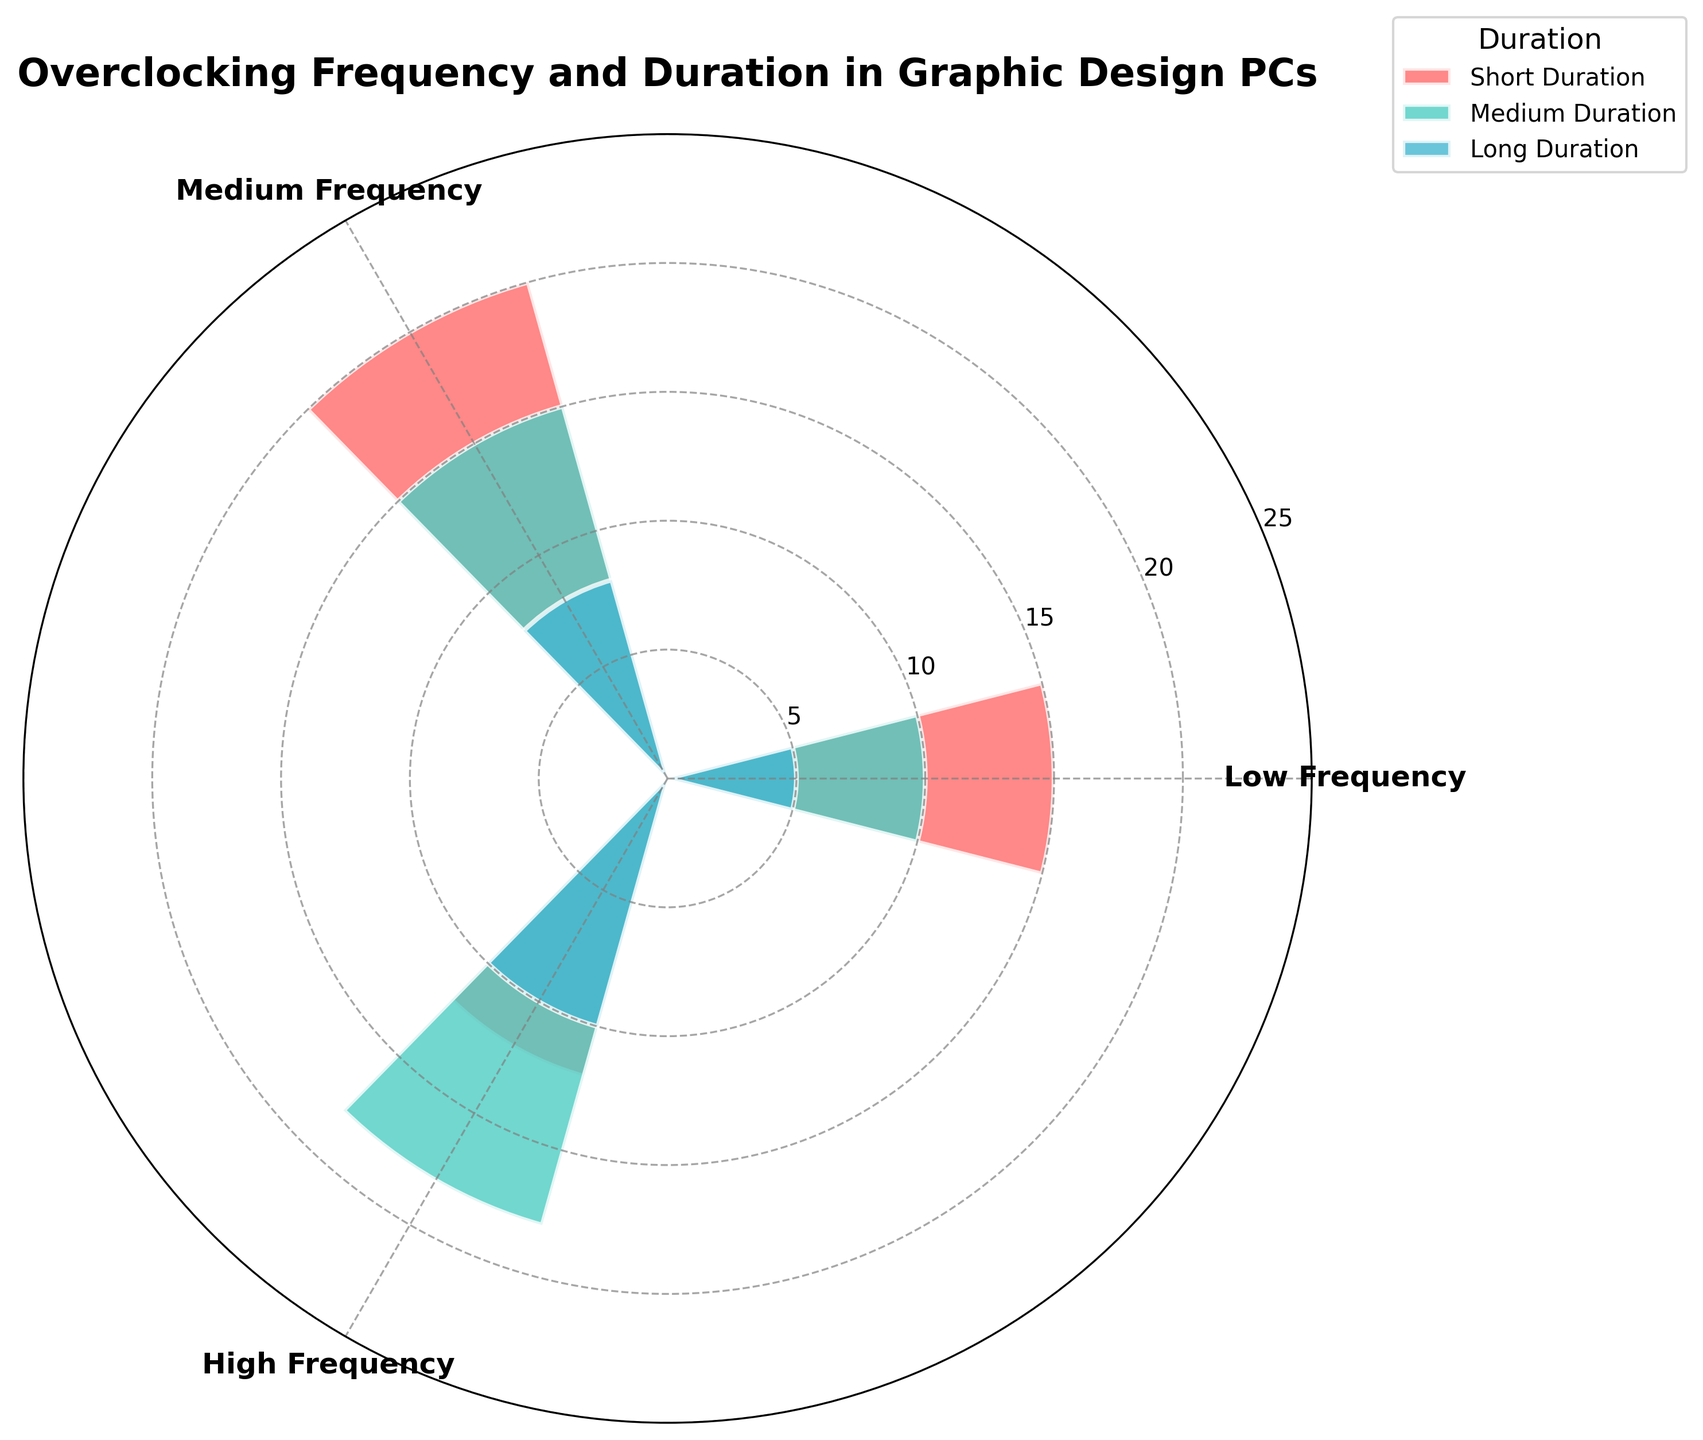What's the title of the chart? The title is usually placed at the top and often centered, it provides a summary of what the chart represents. In this case, it is written in bold.
Answer: Overclocking Frequency and Duration in Graphic Design PCs How many frequency groups are represented in the chart? There are three categories visible along the circular axis, each representing different frequency groups. These are noted by the distinct labels spread evenly around the chart.
Answer: 3 Which duration group has the highest count in the Low Frequency group? In the Low Frequency section, each bar represents a duration group. The tallest bar, which extends the furthest from the center, indicates the highest count.
Answer: Short Duration For the Medium Frequency group, what is the total count of overclocking durations? To find the total count for the Medium Frequency group, you sum the counts for Short, Medium, and Long Duration bars within this section.
Answer: 43 Which duration group shows the highest count in the High Frequency group? The High Frequency section contains three bars representing different durations. The bar that extends furthest out from the center denotes the highest count.
Answer: Medium Duration Compare the counts of Medium Duration between the Low Frequency and High Frequency groups. The heights of the Medium Duration bars in the respective sections indicate their values. Comparing them means identifying which bar is taller.
Answer: High Frequency What is the sum of all counts for Long Duration across all frequency groups? You need to add together the counts of Long Duration from Low, Medium, and High Frequency groups. This involves summing 5, 8, and 10.
Answer: 23 Which frequency group has the highest overclocking count in Short Duration? By examining the Short Duration bars across each frequency group, the group with the longest bar will have the highest count.
Answer: Medium Frequency What is the average count of Medium Duration across all frequency groups? To find this, you sum the counts for Medium Duration (10 + 15 + 18) and then divide by the number of groups (3). Calculation: (10 + 15 + 18) / 3.
Answer: 14.33 Is the count of Long Duration in the High Frequency group greater than the count of Long Duration in the Low Frequency group? You compare the heights of the Long Duration bars for High Frequency and Low Frequency groups. The bar with greater height has a higher count.
Answer: Yes 